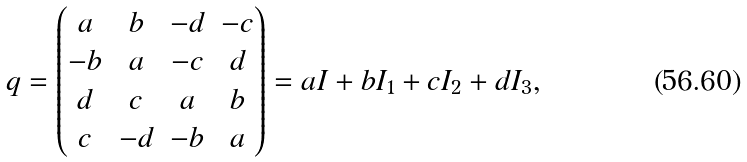<formula> <loc_0><loc_0><loc_500><loc_500>q = \left ( \begin{matrix} a & b & - d & - c \\ - b & a & - c & d \\ d & c & a & b \\ c & - d & - b & a \\ \end{matrix} \right ) = a I + b I _ { 1 } + c I _ { 2 } + d I _ { 3 } ,</formula> 